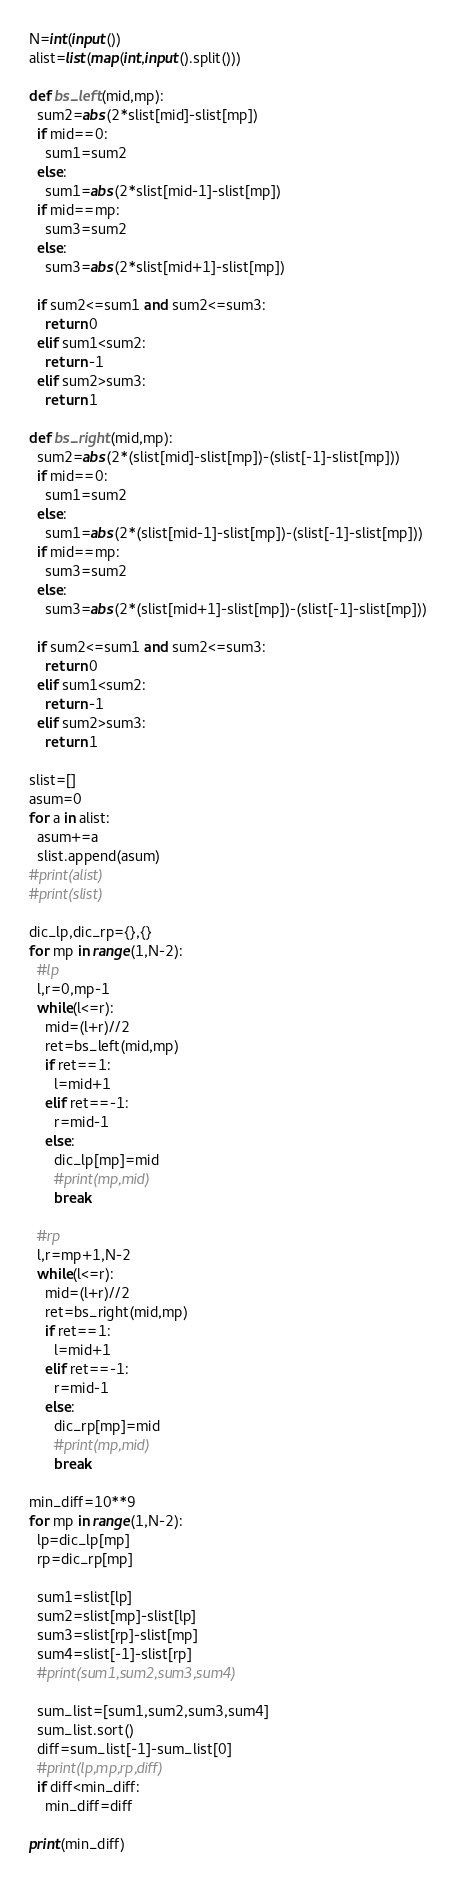Convert code to text. <code><loc_0><loc_0><loc_500><loc_500><_Python_>N=int(input())
alist=list(map(int,input().split()))

def bs_left(mid,mp):
  sum2=abs(2*slist[mid]-slist[mp])
  if mid==0:
    sum1=sum2
  else:
    sum1=abs(2*slist[mid-1]-slist[mp])
  if mid==mp:
    sum3=sum2
  else:
    sum3=abs(2*slist[mid+1]-slist[mp])

  if sum2<=sum1 and sum2<=sum3:
    return 0
  elif sum1<sum2:
    return -1
  elif sum2>sum3:
    return 1    

def bs_right(mid,mp):
  sum2=abs(2*(slist[mid]-slist[mp])-(slist[-1]-slist[mp]))
  if mid==0:
    sum1=sum2
  else:
    sum1=abs(2*(slist[mid-1]-slist[mp])-(slist[-1]-slist[mp]))
  if mid==mp:
    sum3=sum2
  else:
    sum3=abs(2*(slist[mid+1]-slist[mp])-(slist[-1]-slist[mp]))

  if sum2<=sum1 and sum2<=sum3:
    return 0
  elif sum1<sum2:
    return -1
  elif sum2>sum3:
    return 1    
  
slist=[]
asum=0
for a in alist:
  asum+=a
  slist.append(asum)
#print(alist)
#print(slist)

dic_lp,dic_rp={},{}
for mp in range(1,N-2):  
  #lp
  l,r=0,mp-1
  while(l<=r):
    mid=(l+r)//2
    ret=bs_left(mid,mp)
    if ret==1:
      l=mid+1
    elif ret==-1:
      r=mid-1
    else:
      dic_lp[mp]=mid
      #print(mp,mid)
      break
  
  #rp
  l,r=mp+1,N-2
  while(l<=r):
    mid=(l+r)//2
    ret=bs_right(mid,mp)
    if ret==1:
      l=mid+1
    elif ret==-1:
      r=mid-1
    else:
      dic_rp[mp]=mid
      #print(mp,mid)
      break
    
min_diff=10**9
for mp in range(1,N-2):
  lp=dic_lp[mp]
  rp=dic_rp[mp]
  
  sum1=slist[lp]
  sum2=slist[mp]-slist[lp]
  sum3=slist[rp]-slist[mp]
  sum4=slist[-1]-slist[rp]
  #print(sum1,sum2,sum3,sum4)
  
  sum_list=[sum1,sum2,sum3,sum4]
  sum_list.sort()
  diff=sum_list[-1]-sum_list[0]
  #print(lp,mp,rp,diff)
  if diff<min_diff:
    min_diff=diff    
  
print(min_diff)
</code> 